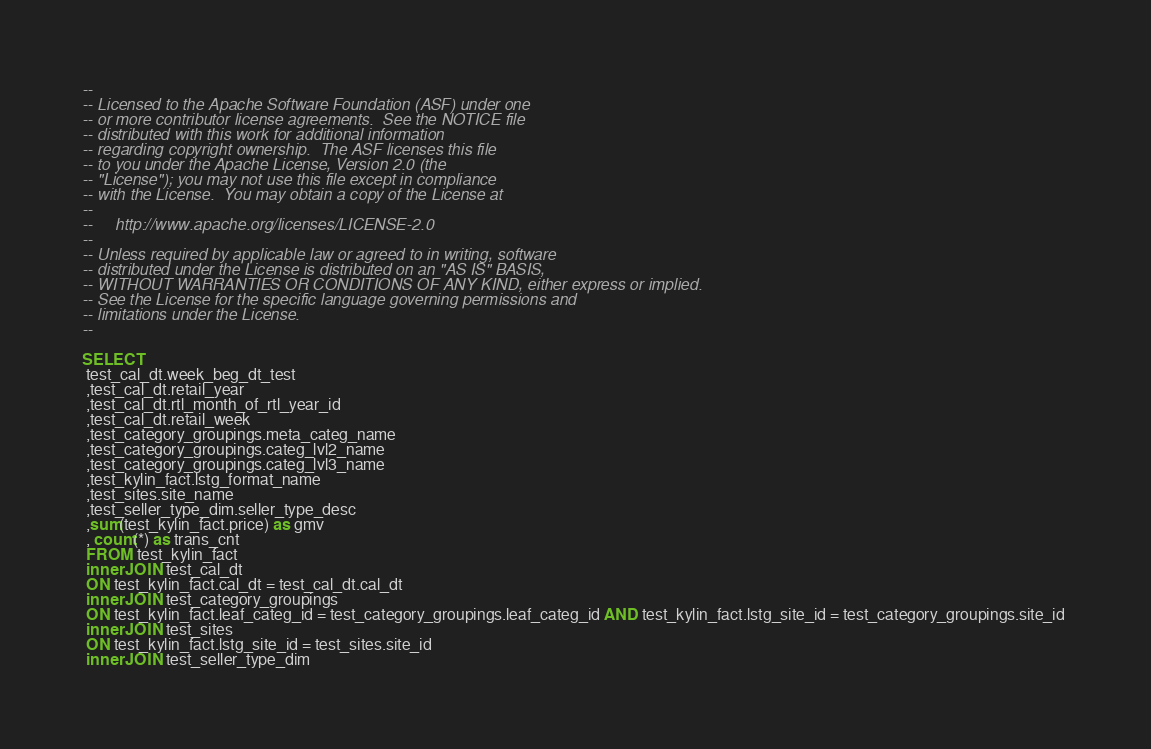<code> <loc_0><loc_0><loc_500><loc_500><_SQL_>--
-- Licensed to the Apache Software Foundation (ASF) under one
-- or more contributor license agreements.  See the NOTICE file
-- distributed with this work for additional information
-- regarding copyright ownership.  The ASF licenses this file
-- to you under the Apache License, Version 2.0 (the
-- "License"); you may not use this file except in compliance
-- with the License.  You may obtain a copy of the License at
--
--     http://www.apache.org/licenses/LICENSE-2.0
--
-- Unless required by applicable law or agreed to in writing, software
-- distributed under the License is distributed on an "AS IS" BASIS,
-- WITHOUT WARRANTIES OR CONDITIONS OF ANY KIND, either express or implied.
-- See the License for the specific language governing permissions and
-- limitations under the License.
--

SELECT 
 test_cal_dt.week_beg_dt_test 
 ,test_cal_dt.retail_year 
 ,test_cal_dt.rtl_month_of_rtl_year_id 
 ,test_cal_dt.retail_week 
 ,test_category_groupings.meta_categ_name 
 ,test_category_groupings.categ_lvl2_name 
 ,test_category_groupings.categ_lvl3_name 
 ,test_kylin_fact.lstg_format_name 
 ,test_sites.site_name 
 ,test_seller_type_dim.seller_type_desc 
 ,sum(test_kylin_fact.price) as gmv 
 , count(*) as trans_cnt 
 FROM test_kylin_fact 
 inner JOIN test_cal_dt 
 ON test_kylin_fact.cal_dt = test_cal_dt.cal_dt 
 inner JOIN test_category_groupings 
 ON test_kylin_fact.leaf_categ_id = test_category_groupings.leaf_categ_id AND test_kylin_fact.lstg_site_id = test_category_groupings.site_id 
 inner JOIN test_sites 
 ON test_kylin_fact.lstg_site_id = test_sites.site_id 
 inner JOIN test_seller_type_dim </code> 